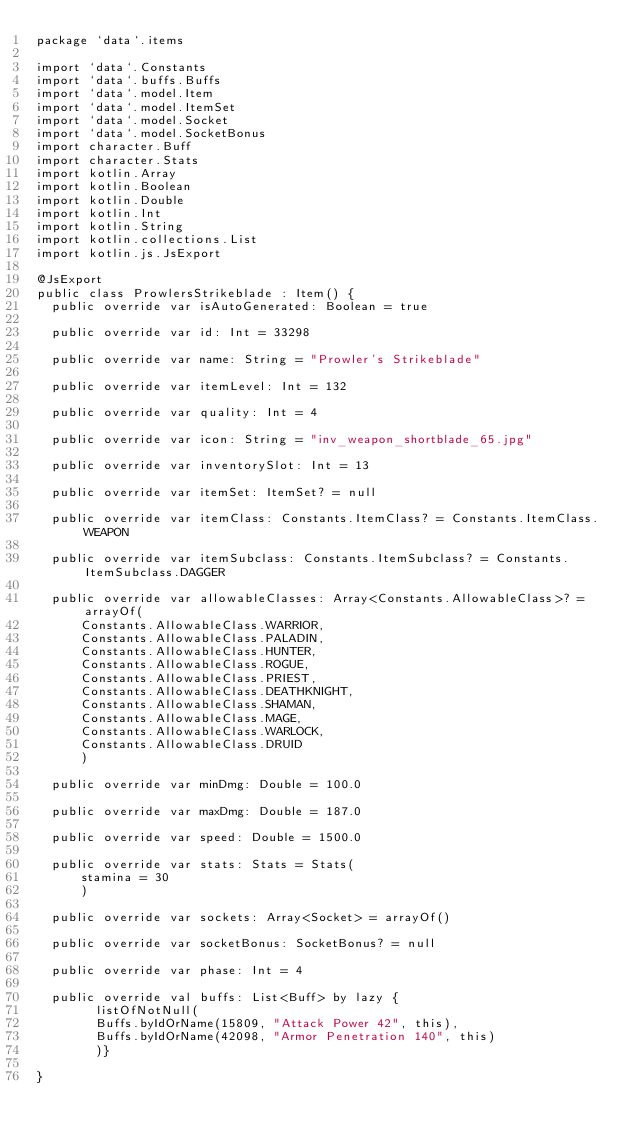<code> <loc_0><loc_0><loc_500><loc_500><_Kotlin_>package `data`.items

import `data`.Constants
import `data`.buffs.Buffs
import `data`.model.Item
import `data`.model.ItemSet
import `data`.model.Socket
import `data`.model.SocketBonus
import character.Buff
import character.Stats
import kotlin.Array
import kotlin.Boolean
import kotlin.Double
import kotlin.Int
import kotlin.String
import kotlin.collections.List
import kotlin.js.JsExport

@JsExport
public class ProwlersStrikeblade : Item() {
  public override var isAutoGenerated: Boolean = true

  public override var id: Int = 33298

  public override var name: String = "Prowler's Strikeblade"

  public override var itemLevel: Int = 132

  public override var quality: Int = 4

  public override var icon: String = "inv_weapon_shortblade_65.jpg"

  public override var inventorySlot: Int = 13

  public override var itemSet: ItemSet? = null

  public override var itemClass: Constants.ItemClass? = Constants.ItemClass.WEAPON

  public override var itemSubclass: Constants.ItemSubclass? = Constants.ItemSubclass.DAGGER

  public override var allowableClasses: Array<Constants.AllowableClass>? = arrayOf(
      Constants.AllowableClass.WARRIOR,
      Constants.AllowableClass.PALADIN,
      Constants.AllowableClass.HUNTER,
      Constants.AllowableClass.ROGUE,
      Constants.AllowableClass.PRIEST,
      Constants.AllowableClass.DEATHKNIGHT,
      Constants.AllowableClass.SHAMAN,
      Constants.AllowableClass.MAGE,
      Constants.AllowableClass.WARLOCK,
      Constants.AllowableClass.DRUID
      )

  public override var minDmg: Double = 100.0

  public override var maxDmg: Double = 187.0

  public override var speed: Double = 1500.0

  public override var stats: Stats = Stats(
      stamina = 30
      )

  public override var sockets: Array<Socket> = arrayOf()

  public override var socketBonus: SocketBonus? = null

  public override var phase: Int = 4

  public override val buffs: List<Buff> by lazy {
        listOfNotNull(
        Buffs.byIdOrName(15809, "Attack Power 42", this),
        Buffs.byIdOrName(42098, "Armor Penetration 140", this)
        )}

}
</code> 